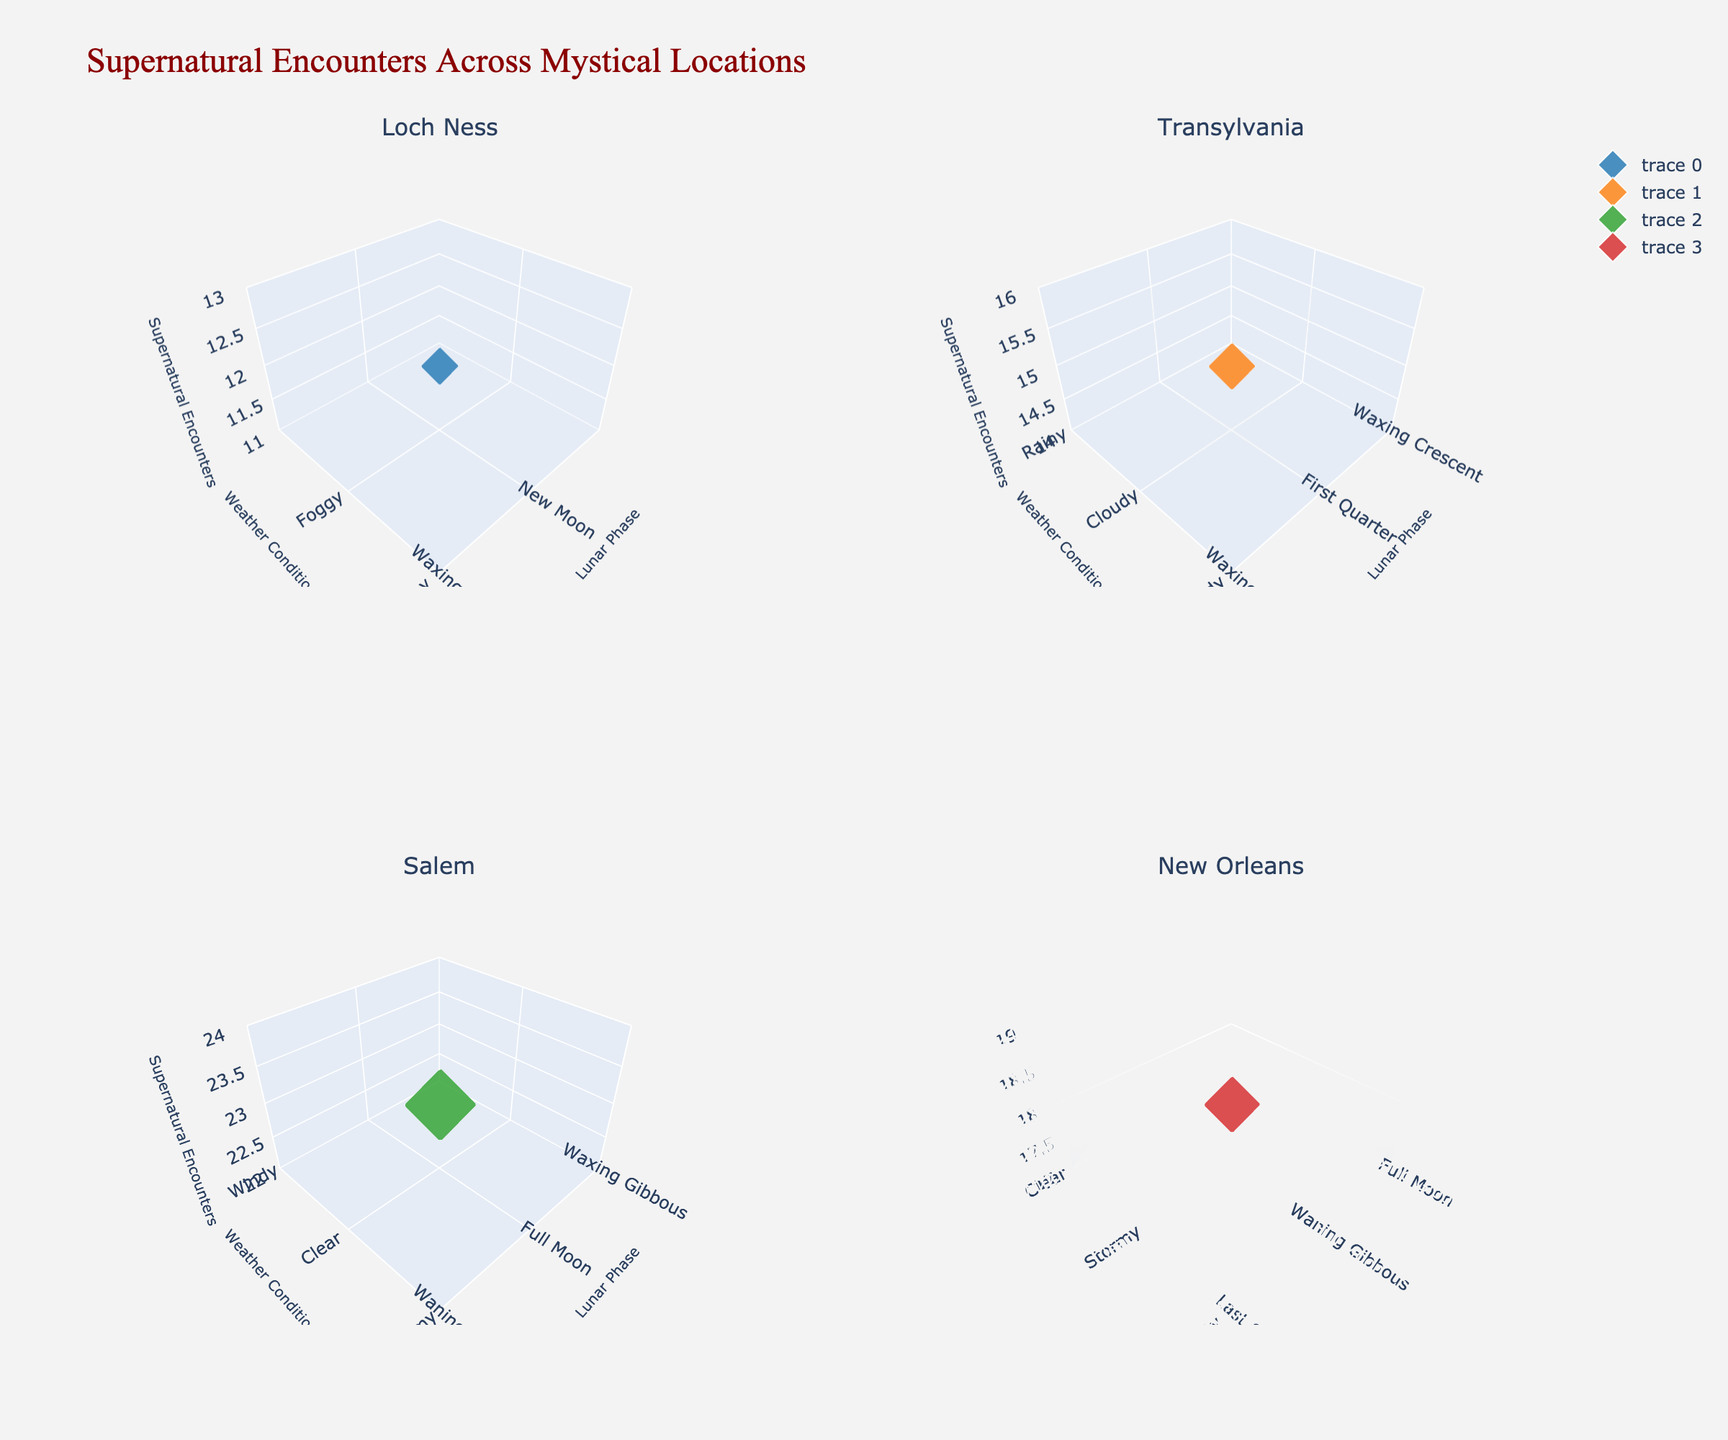What is the title of the figure? The title is displayed prominently at the top of the figure. It sets the context for the data presented in the subplots.
Answer: Supernatural Encounters Across Mystical Locations How many subplots are present in the figure? The figure is subdivided into multiple sections, each representing a specific location. Count the number of such sections.
Answer: 4 Which location has the highest recorded number of supernatural encounters during a full moon? Look for the subplot title corresponding to each location, and then identify the highest z-value (representing supernatural encounters) during the full moon phase within that subplot.
Answer: Salem What is the most common weather condition for supernatural encounters in Loch Ness? Examine the subplot for Loch Ness and identify the weather condition that appears most frequently.
Answer: Foggy Compare the number of supernatural encounters in Transylvania during the first quarter moon with those in New Orleans during a stormy night. Which location has more encounters? Refer to the subplot for Transylvania and note the z-value corresponding to the first quarter moon. Similarly, check the subplot for New Orleans for the stormy night to compare the values.
Answer: Transylvania How does the number of supernatural encounters in Salem during a clear night compare to the number during a foggy night? Locate the subplot for Salem and identify the z-values for clear and foggy conditions. Compare these two values.
Answer: Clear night has more encounters than foggy night What is the average number of supernatural encounters in Salem across all weather conditions? List the z-values for all weather conditions in the Salem subplot, sum them up, and divide by the number of weather conditions. For example: (23 for clear + any other values for other weather conditions) / number of weather conditions = average.
Answer: 21.5 In Loch Ness, does the new moon phase tend to have more or fewer supernatural encounters compared to the full moon phase? Compare the z-values for new moon and full moon phases in the Loch Ness subplot.
Answer: New moon has fewer encounters than full moon Which location shows the widest range of lunar phases associated with supernatural encounters? Observe each subplot and count the number of different lunar phases shown in terms of x-values. The one with the highest count indicates the widest range.
Answer: Salem 